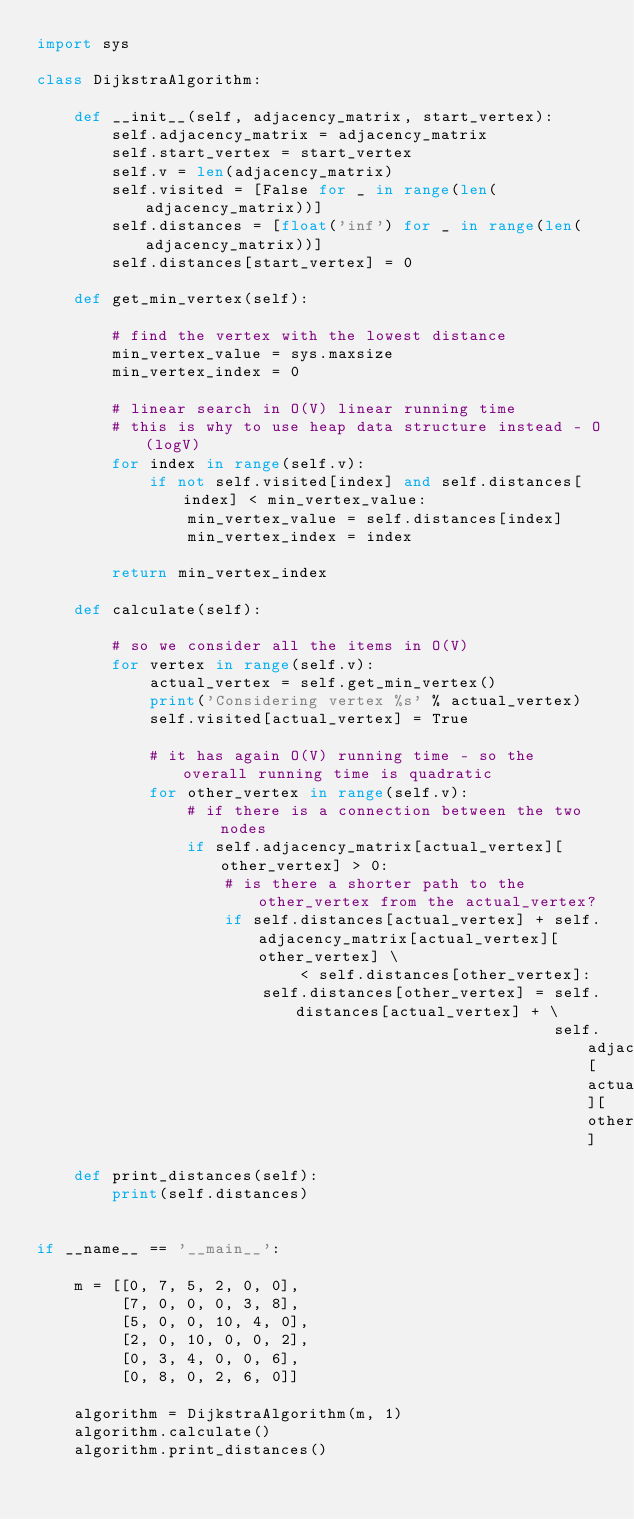Convert code to text. <code><loc_0><loc_0><loc_500><loc_500><_Python_>import sys

class DijkstraAlgorithm:

    def __init__(self, adjacency_matrix, start_vertex):
        self.adjacency_matrix = adjacency_matrix
        self.start_vertex = start_vertex
        self.v = len(adjacency_matrix)
        self.visited = [False for _ in range(len(adjacency_matrix))]
        self.distances = [float('inf') for _ in range(len(adjacency_matrix))]
        self.distances[start_vertex] = 0

    def get_min_vertex(self):

        # find the vertex with the lowest distance
        min_vertex_value = sys.maxsize
        min_vertex_index = 0

        # linear search in O(V) linear running time
        # this is why to use heap data structure instead - O(logV)
        for index in range(self.v):
            if not self.visited[index] and self.distances[index] < min_vertex_value:
                min_vertex_value = self.distances[index]
                min_vertex_index = index

        return min_vertex_index

    def calculate(self):

        # so we consider all the items in O(V)
        for vertex in range(self.v):
            actual_vertex = self.get_min_vertex()
            print('Considering vertex %s' % actual_vertex)
            self.visited[actual_vertex] = True

            # it has again O(V) running time - so the overall running time is quadratic
            for other_vertex in range(self.v):
                # if there is a connection between the two nodes
                if self.adjacency_matrix[actual_vertex][other_vertex] > 0:
                    # is there a shorter path to the other_vertex from the actual_vertex?
                    if self.distances[actual_vertex] + self.adjacency_matrix[actual_vertex][other_vertex] \
                            < self.distances[other_vertex]:
                        self.distances[other_vertex] = self.distances[actual_vertex] + \
                                                       self.adjacency_matrix[actual_vertex][other_vertex]

    def print_distances(self):
        print(self.distances)


if __name__ == '__main__':

    m = [[0, 7, 5, 2, 0, 0],
         [7, 0, 0, 0, 3, 8],
         [5, 0, 0, 10, 4, 0],
         [2, 0, 10, 0, 0, 2],
         [0, 3, 4, 0, 0, 6],
         [0, 8, 0, 2, 6, 0]]

    algorithm = DijkstraAlgorithm(m, 1)
    algorithm.calculate()
    algorithm.print_distances()
</code> 